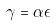Convert formula to latex. <formula><loc_0><loc_0><loc_500><loc_500>\gamma = \alpha \epsilon</formula> 